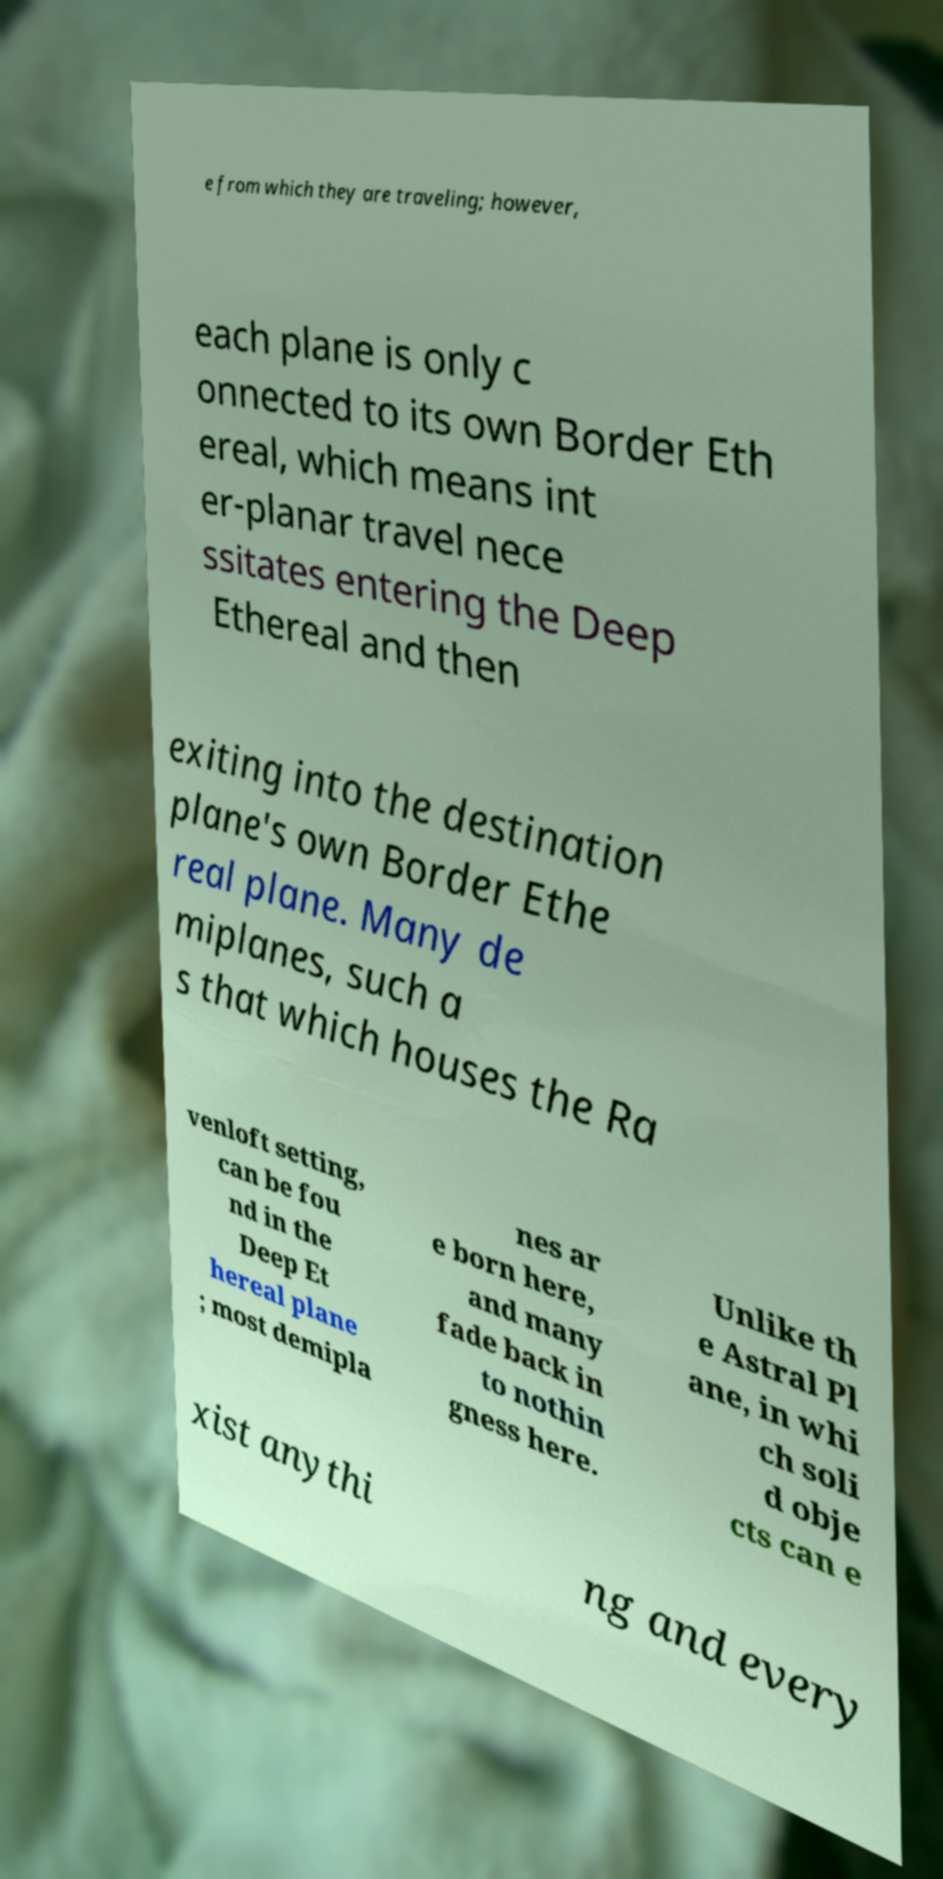For documentation purposes, I need the text within this image transcribed. Could you provide that? e from which they are traveling; however, each plane is only c onnected to its own Border Eth ereal, which means int er-planar travel nece ssitates entering the Deep Ethereal and then exiting into the destination plane's own Border Ethe real plane. Many de miplanes, such a s that which houses the Ra venloft setting, can be fou nd in the Deep Et hereal plane ; most demipla nes ar e born here, and many fade back in to nothin gness here. Unlike th e Astral Pl ane, in whi ch soli d obje cts can e xist anythi ng and every 